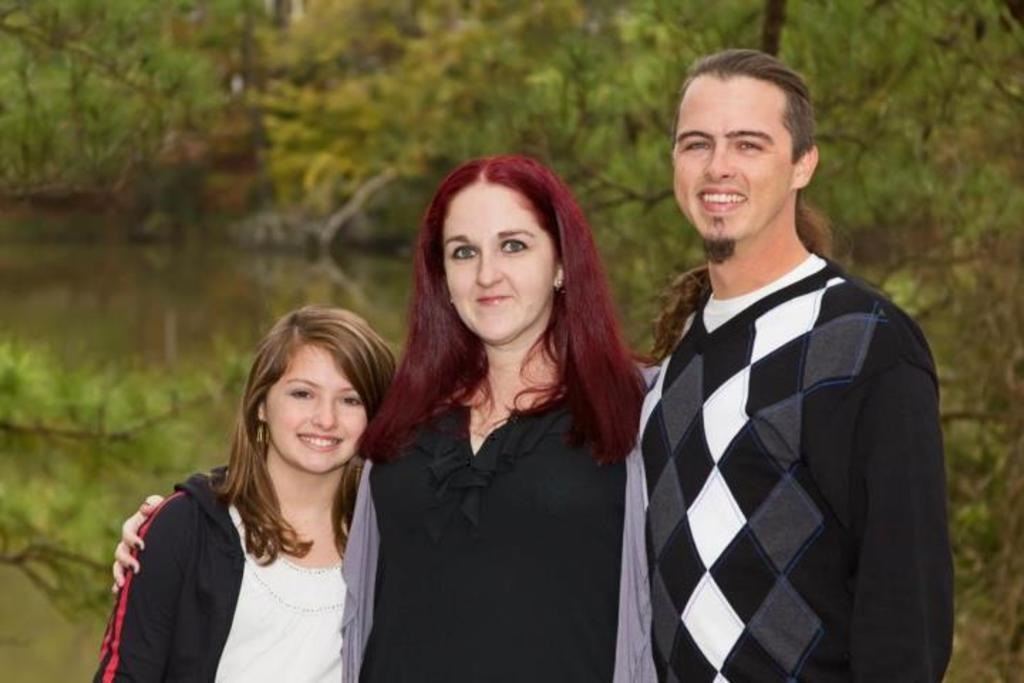How many people are in the image? There are three persons in the image. What are the persons doing in the image? The persons are standing in the image. What expressions do the persons have in the image? The persons are smiling in the image. What can be seen in the background of the image? There are trees in the background of the image. What type of metal can be seen in the image? There is no metal present in the image. How does the sense of smell play a role in the image? The sense of smell does not play a role in the image, as it is a visual representation and does not involve any scents. 